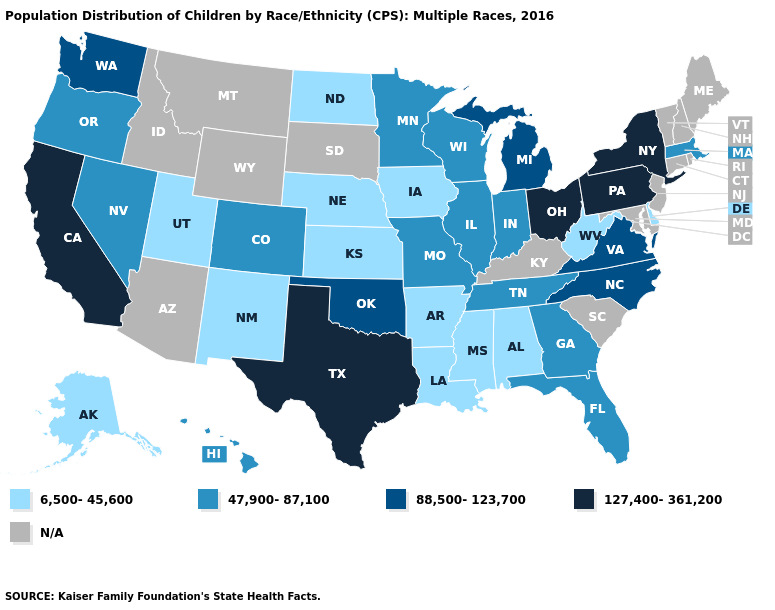Does Nevada have the lowest value in the West?
Quick response, please. No. Which states have the highest value in the USA?
Write a very short answer. California, New York, Ohio, Pennsylvania, Texas. What is the value of Kentucky?
Write a very short answer. N/A. What is the value of Oklahoma?
Keep it brief. 88,500-123,700. What is the value of Massachusetts?
Write a very short answer. 47,900-87,100. Does Ohio have the lowest value in the USA?
Write a very short answer. No. How many symbols are there in the legend?
Short answer required. 5. Name the states that have a value in the range 6,500-45,600?
Short answer required. Alabama, Alaska, Arkansas, Delaware, Iowa, Kansas, Louisiana, Mississippi, Nebraska, New Mexico, North Dakota, Utah, West Virginia. Does Washington have the highest value in the USA?
Concise answer only. No. Does the first symbol in the legend represent the smallest category?
Quick response, please. Yes. Does the map have missing data?
Keep it brief. Yes. Does the map have missing data?
Be succinct. Yes. What is the value of Connecticut?
Short answer required. N/A. 